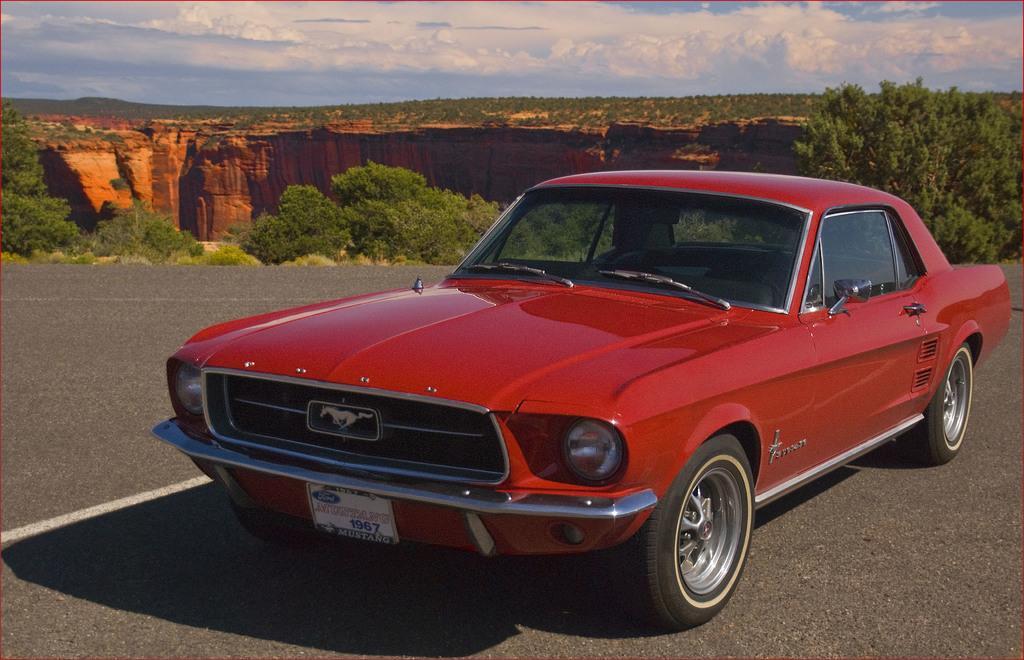Can you describe this image briefly? In this picture I can see a car parked and I can see few trees and I can see blue cloudy sky. 